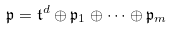Convert formula to latex. <formula><loc_0><loc_0><loc_500><loc_500>\mathfrak { p } = \mathfrak { t } ^ { d } \oplus \mathfrak { p } _ { 1 } \oplus \dots \oplus \mathfrak { p } _ { m }</formula> 